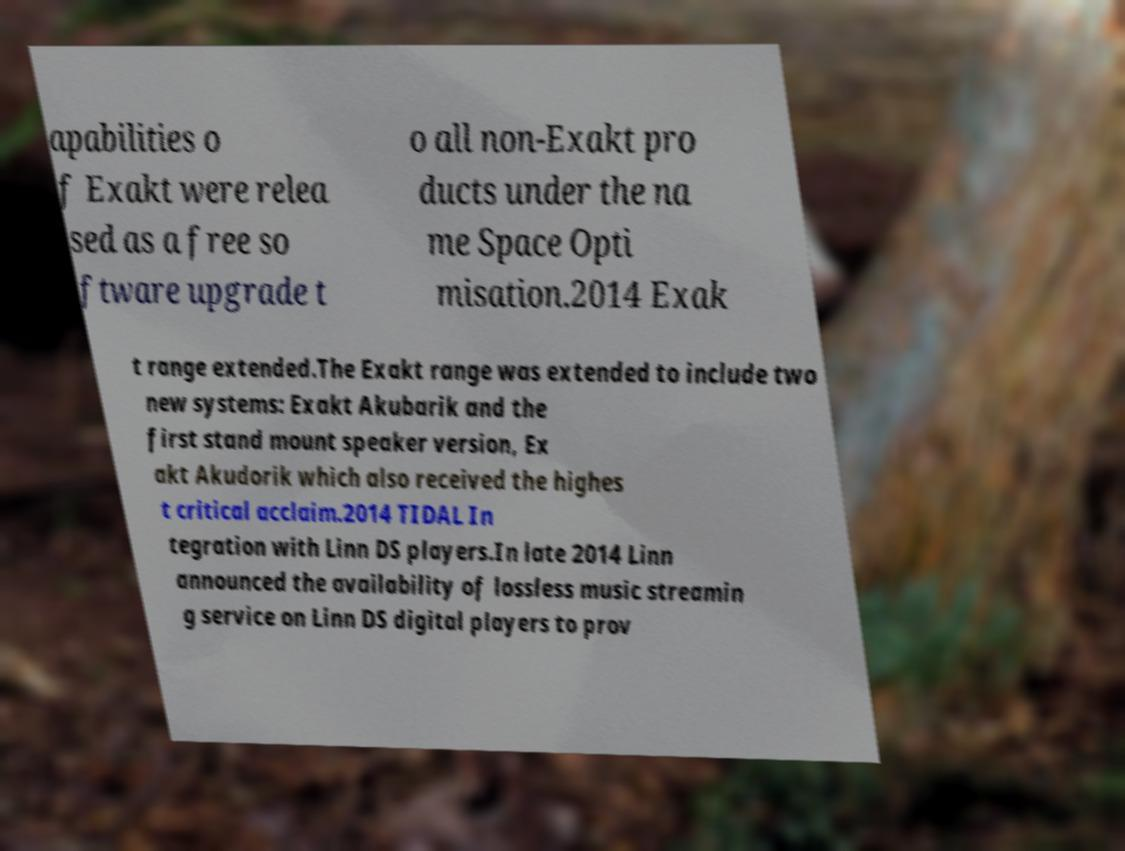Please identify and transcribe the text found in this image. apabilities o f Exakt were relea sed as a free so ftware upgrade t o all non-Exakt pro ducts under the na me Space Opti misation.2014 Exak t range extended.The Exakt range was extended to include two new systems: Exakt Akubarik and the first stand mount speaker version, Ex akt Akudorik which also received the highes t critical acclaim.2014 TIDAL In tegration with Linn DS players.In late 2014 Linn announced the availability of lossless music streamin g service on Linn DS digital players to prov 